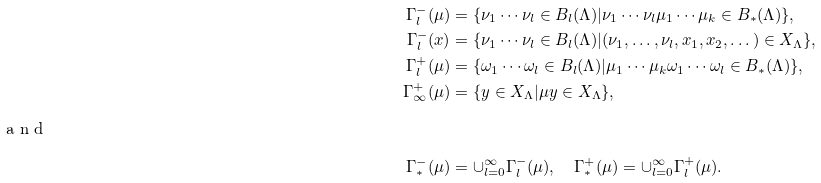<formula> <loc_0><loc_0><loc_500><loc_500>\Gamma _ { l } ^ { - } ( \mu ) & = \{ \nu _ { 1 } \cdots \nu _ { l } \in B _ { l } ( \Lambda ) | \nu _ { 1 } \cdots \nu _ { l } \mu _ { 1 } \cdots \mu _ { k } \in B _ { * } ( \Lambda ) \} , \\ \Gamma _ { l } ^ { - } ( x ) & = \{ \nu _ { 1 } \cdots \nu _ { l } \in B _ { l } ( \Lambda ) | ( \nu _ { 1 } , \dots , \nu _ { l } , x _ { 1 } , x _ { 2 } , \dots ) \in X _ { \Lambda } \} , \\ \Gamma _ { l } ^ { + } ( \mu ) & = \{ \omega _ { 1 } \cdots \omega _ { l } \in B _ { l } ( \Lambda ) | \mu _ { 1 } \cdots \mu _ { k } \omega _ { 1 } \cdots \omega _ { l } \in B _ { * } ( \Lambda ) \} , \\ \Gamma _ { \infty } ^ { + } ( \mu ) & = \{ y \in X _ { \Lambda } | \mu y \in X _ { \Lambda } \} , \\ \intertext { a n d } \Gamma _ { * } ^ { - } ( \mu ) & = \cup _ { l = 0 } ^ { \infty } \Gamma _ { l } ^ { - } ( \mu ) , \quad \Gamma _ { * } ^ { + } ( \mu ) = \cup _ { l = 0 } ^ { \infty } \Gamma _ { l } ^ { + } ( \mu ) .</formula> 